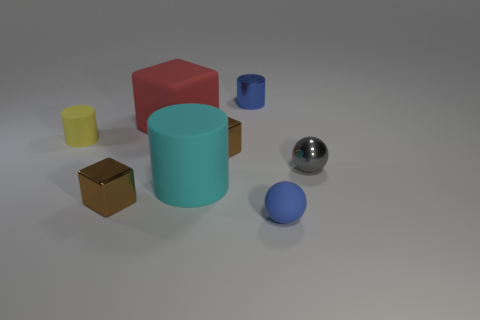Are there any big rubber blocks that have the same color as the metallic sphere?
Make the answer very short. No. Are there the same number of blue objects in front of the tiny yellow cylinder and metal spheres?
Offer a very short reply. Yes. What number of small brown metallic cubes are there?
Your response must be concise. 2. There is a small object that is both in front of the big cyan rubber cylinder and on the left side of the large red rubber thing; what is its shape?
Provide a succinct answer. Cube. Does the tiny cylinder to the right of the big rubber cylinder have the same color as the tiny metallic block that is behind the small gray object?
Make the answer very short. No. There is a object that is the same color as the rubber ball; what is its size?
Ensure brevity in your answer.  Small. Is there a small cyan sphere made of the same material as the cyan object?
Ensure brevity in your answer.  No. Are there an equal number of metallic cylinders that are behind the yellow thing and tiny objects that are on the right side of the shiny sphere?
Your response must be concise. No. There is a brown object behind the cyan object; what is its size?
Your answer should be compact. Small. What is the material of the sphere that is right of the small blue thing that is in front of the yellow matte cylinder?
Offer a terse response. Metal. 